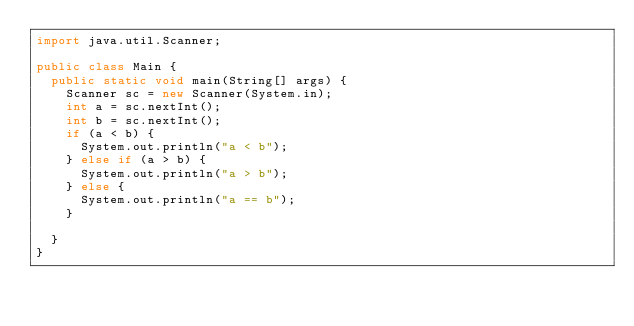Convert code to text. <code><loc_0><loc_0><loc_500><loc_500><_Java_>import java.util.Scanner;

public class Main {
	public static void main(String[] args) {
		Scanner sc = new Scanner(System.in);
		int a = sc.nextInt();
		int b = sc.nextInt();
		if (a < b) {
			System.out.println("a < b");
		} else if (a > b) {
			System.out.println("a > b");
		} else {
			System.out.println("a == b");
		}

	}
}</code> 